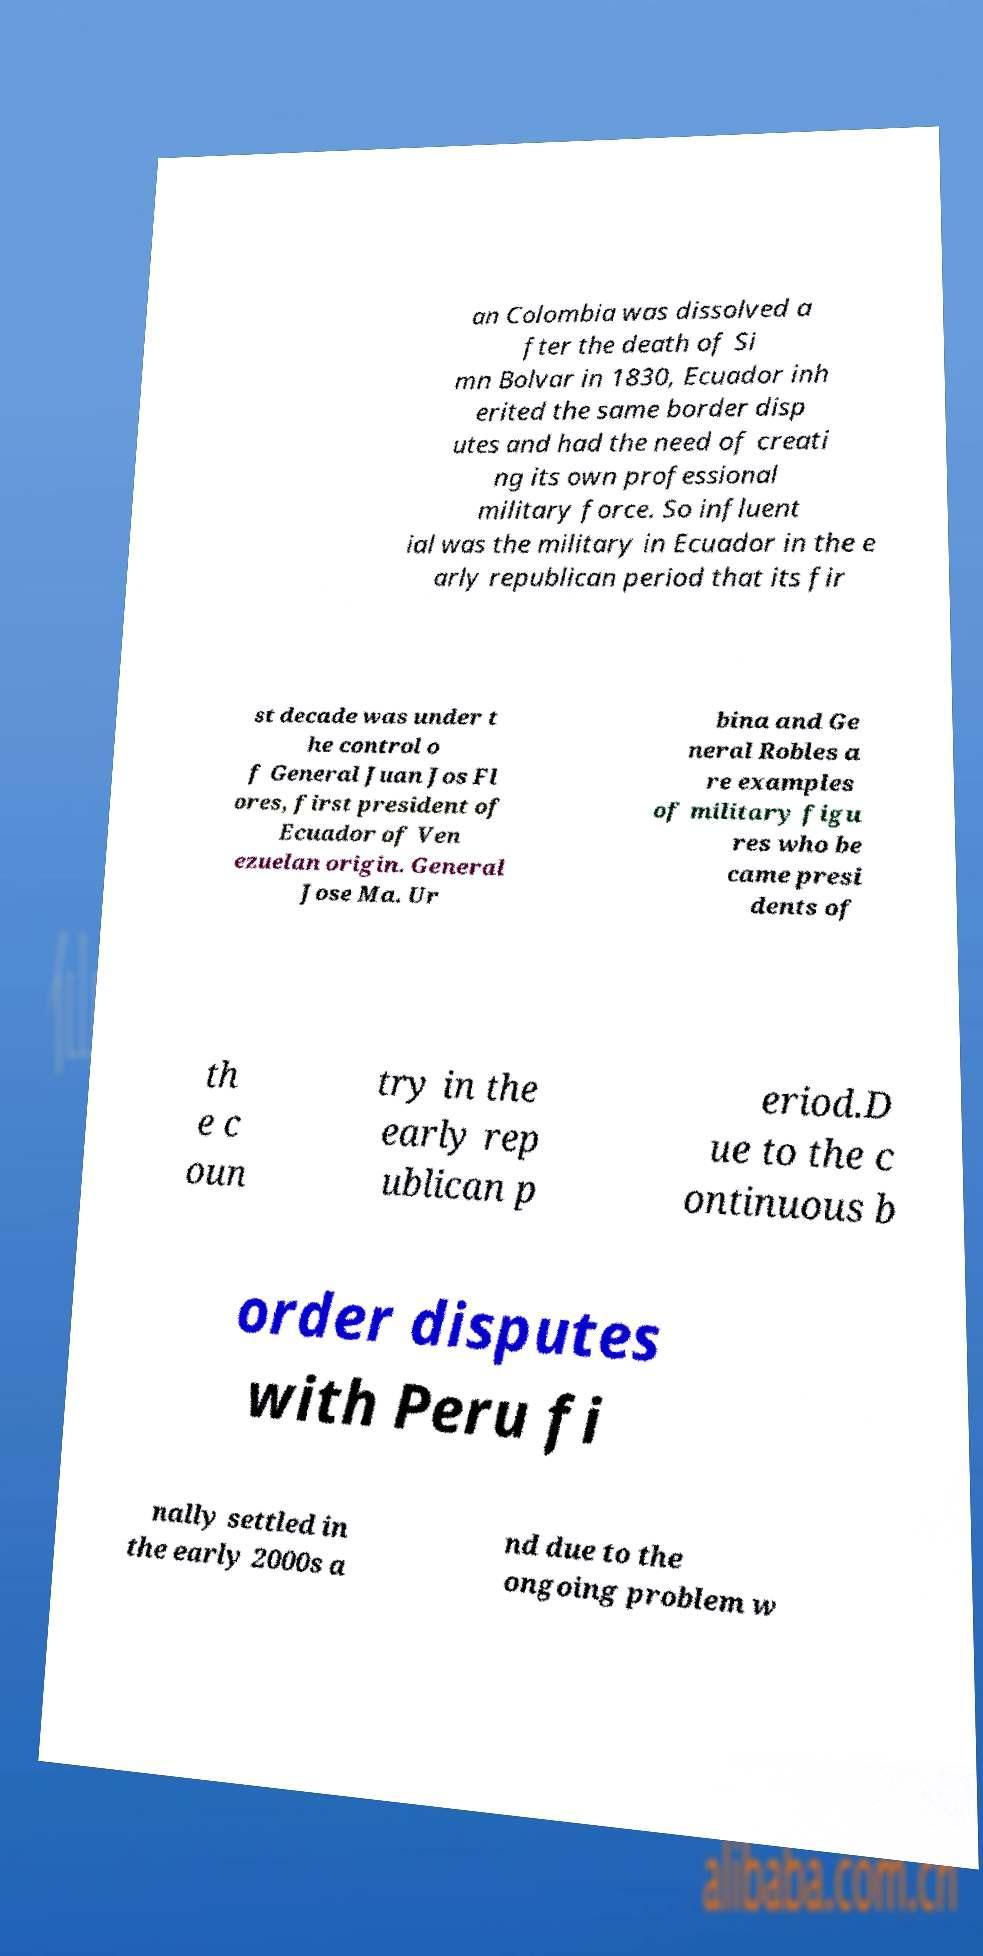What messages or text are displayed in this image? I need them in a readable, typed format. an Colombia was dissolved a fter the death of Si mn Bolvar in 1830, Ecuador inh erited the same border disp utes and had the need of creati ng its own professional military force. So influent ial was the military in Ecuador in the e arly republican period that its fir st decade was under t he control o f General Juan Jos Fl ores, first president of Ecuador of Ven ezuelan origin. General Jose Ma. Ur bina and Ge neral Robles a re examples of military figu res who be came presi dents of th e c oun try in the early rep ublican p eriod.D ue to the c ontinuous b order disputes with Peru fi nally settled in the early 2000s a nd due to the ongoing problem w 